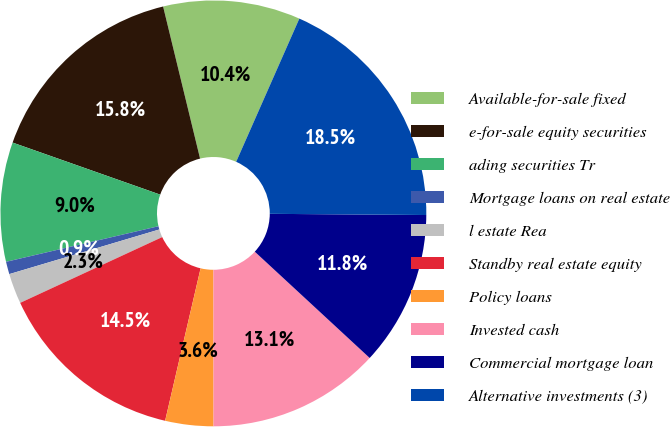Convert chart. <chart><loc_0><loc_0><loc_500><loc_500><pie_chart><fcel>Available-for-sale fixed<fcel>e-for-sale equity securities<fcel>ading securities Tr<fcel>Mortgage loans on real estate<fcel>l estate Rea<fcel>Standby real estate equity<fcel>Policy loans<fcel>Invested cash<fcel>Commercial mortgage loan<fcel>Alternative investments (3)<nl><fcel>10.41%<fcel>15.81%<fcel>9.05%<fcel>0.95%<fcel>2.3%<fcel>14.46%<fcel>3.65%<fcel>13.11%<fcel>11.76%<fcel>18.51%<nl></chart> 